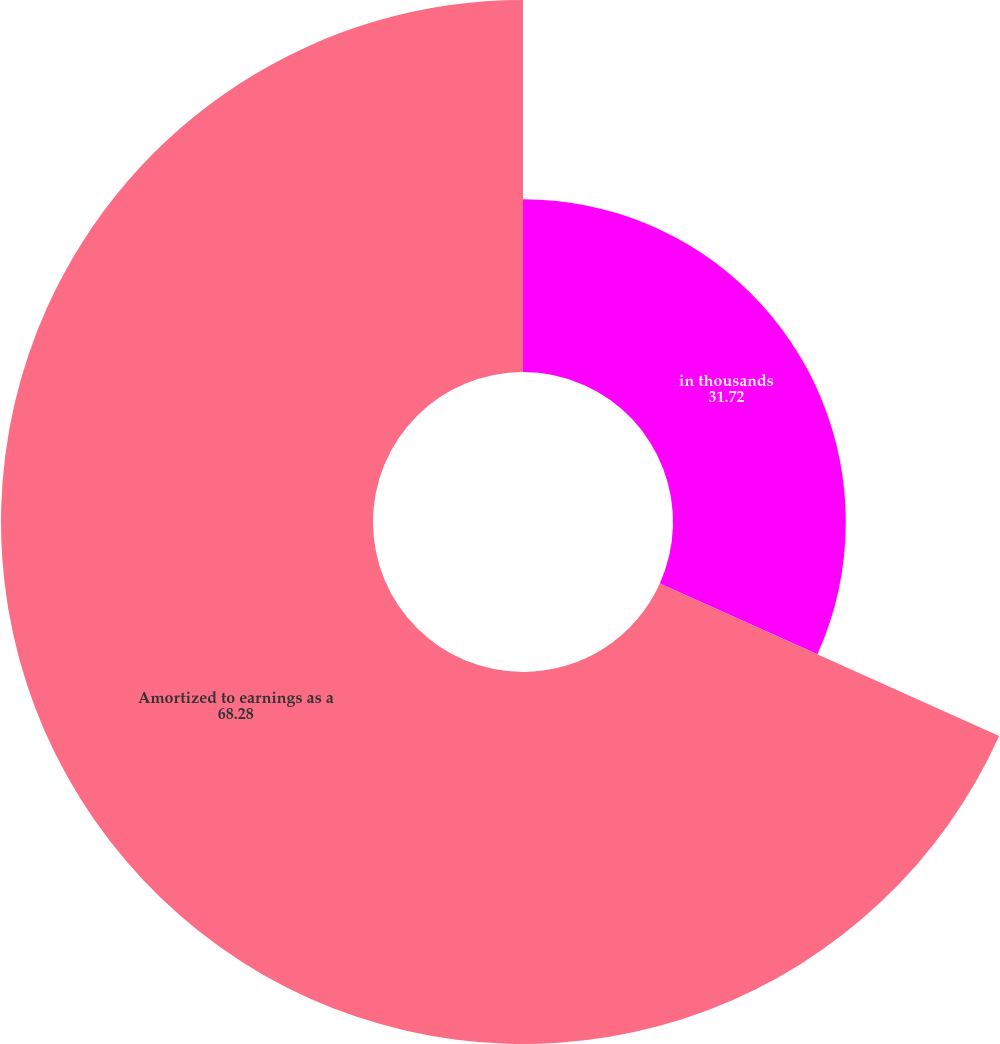Convert chart to OTSL. <chart><loc_0><loc_0><loc_500><loc_500><pie_chart><fcel>in thousands<fcel>Amortized to earnings as a<nl><fcel>31.72%<fcel>68.28%<nl></chart> 